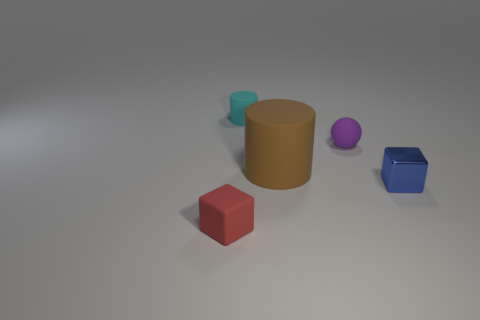There is a small block that is to the right of the red rubber thing; is there a tiny object in front of it?
Give a very brief answer. Yes. Are any green shiny cylinders visible?
Make the answer very short. No. There is a small block behind the block that is on the left side of the purple matte ball; what color is it?
Your answer should be very brief. Blue. What material is the blue object that is the same shape as the red object?
Ensure brevity in your answer.  Metal. How many matte cylinders have the same size as the purple ball?
Keep it short and to the point. 1. The cyan cylinder that is made of the same material as the tiny red object is what size?
Your response must be concise. Small. How many small red objects have the same shape as the small purple rubber thing?
Make the answer very short. 0. How many purple blocks are there?
Make the answer very short. 0. Does the matte object left of the cyan cylinder have the same shape as the big matte object?
Offer a very short reply. No. What material is the cube that is the same size as the blue thing?
Your answer should be compact. Rubber. 